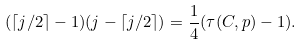<formula> <loc_0><loc_0><loc_500><loc_500>( \lceil j / 2 \rceil - 1 ) ( j - \lceil j / 2 \rceil ) = \frac { 1 } { 4 } ( \tau ( C , p ) - 1 ) .</formula> 